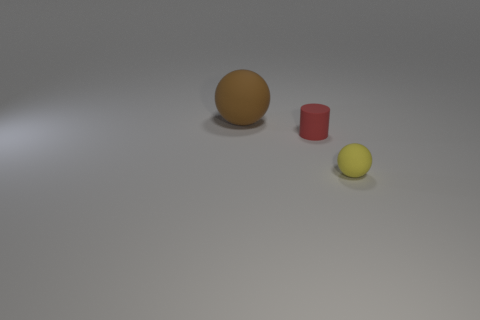Subtract all balls. How many objects are left? 1 Add 1 small purple shiny cylinders. How many objects exist? 4 Subtract all yellow balls. How many balls are left? 1 Subtract 1 yellow balls. How many objects are left? 2 Subtract 1 cylinders. How many cylinders are left? 0 Subtract all purple cylinders. Subtract all cyan cubes. How many cylinders are left? 1 Subtract all brown spheres. How many gray cylinders are left? 0 Subtract all red cylinders. Subtract all purple shiny things. How many objects are left? 2 Add 3 small cylinders. How many small cylinders are left? 4 Add 3 large green metal blocks. How many large green metal blocks exist? 3 